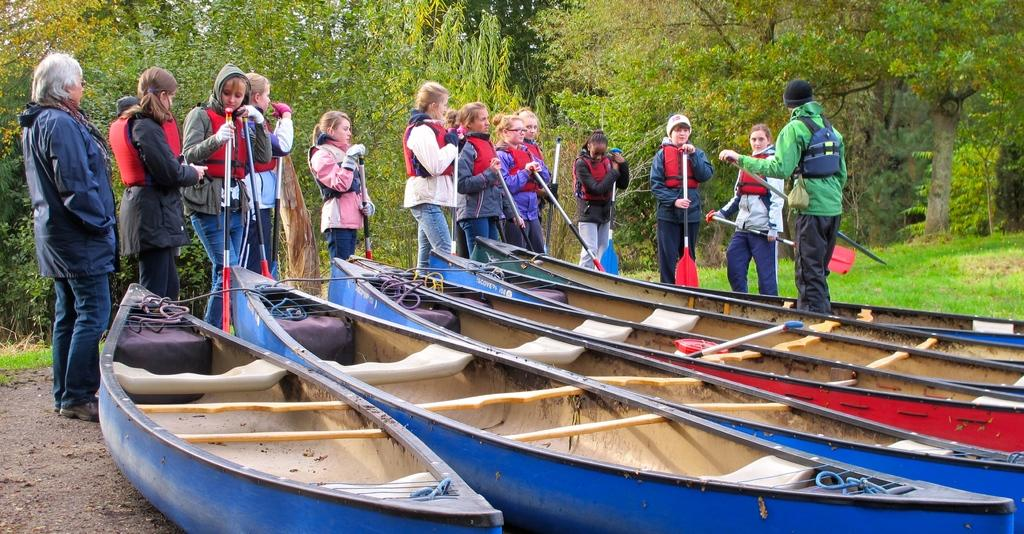What can be seen in the image related to water transportation? There are boats in the image. What is the color of the boats? The boats are blue in color. Who is present near the boats? There are girls standing near the boats. What safety precaution are the girls wearing? The girls are wearing life jackets. What type of vegetation can be seen in the background of the image? There are green color trees in the background of the image. What type of coach is being used for the operation in the image? There is no coach or operation present in the image; it features boats and girls near them. 